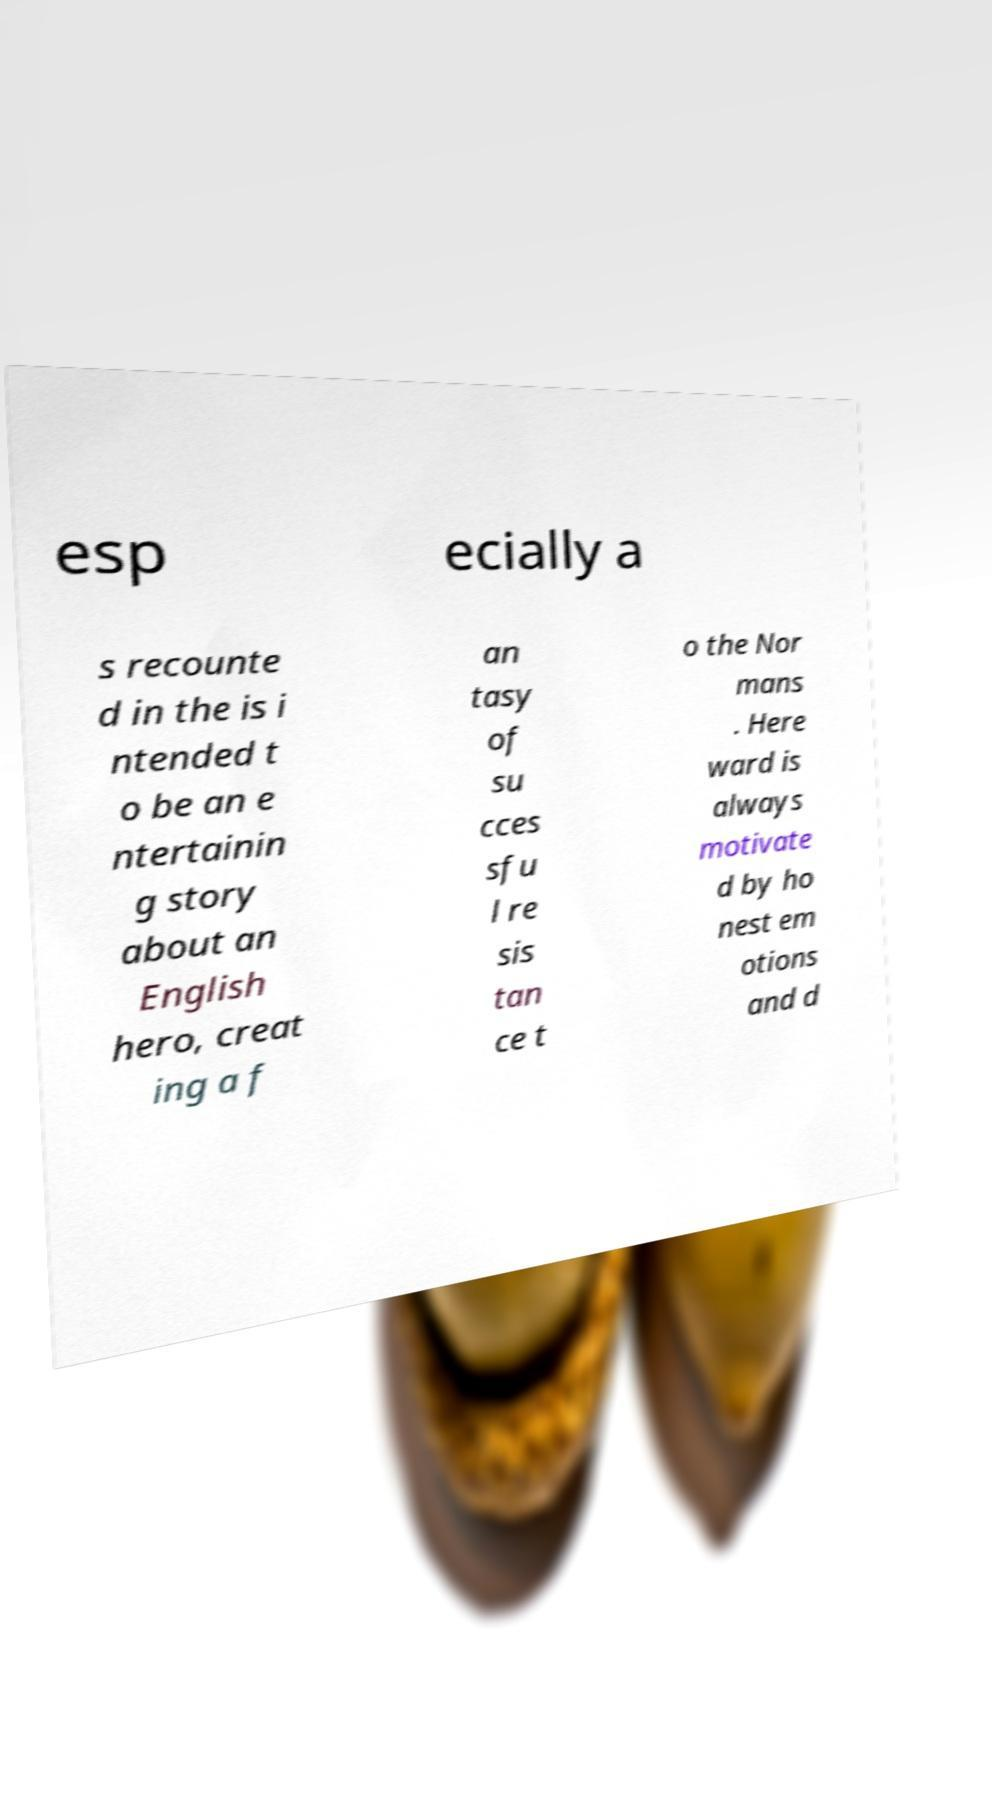I need the written content from this picture converted into text. Can you do that? esp ecially a s recounte d in the is i ntended t o be an e ntertainin g story about an English hero, creat ing a f an tasy of su cces sfu l re sis tan ce t o the Nor mans . Here ward is always motivate d by ho nest em otions and d 